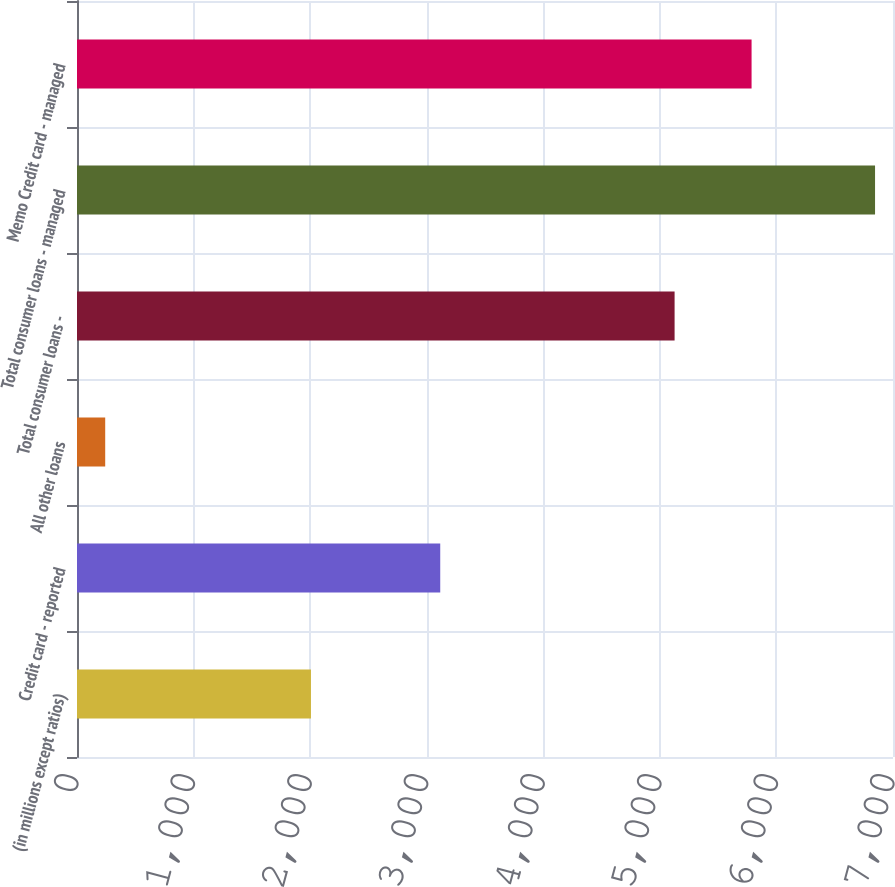<chart> <loc_0><loc_0><loc_500><loc_500><bar_chart><fcel>(in millions except ratios)<fcel>Credit card - reported<fcel>All other loans<fcel>Total consumer loans -<fcel>Total consumer loans - managed<fcel>Memo Credit card - managed<nl><fcel>2007<fcel>3116<fcel>242<fcel>5126.4<fcel>6846<fcel>5786.8<nl></chart> 